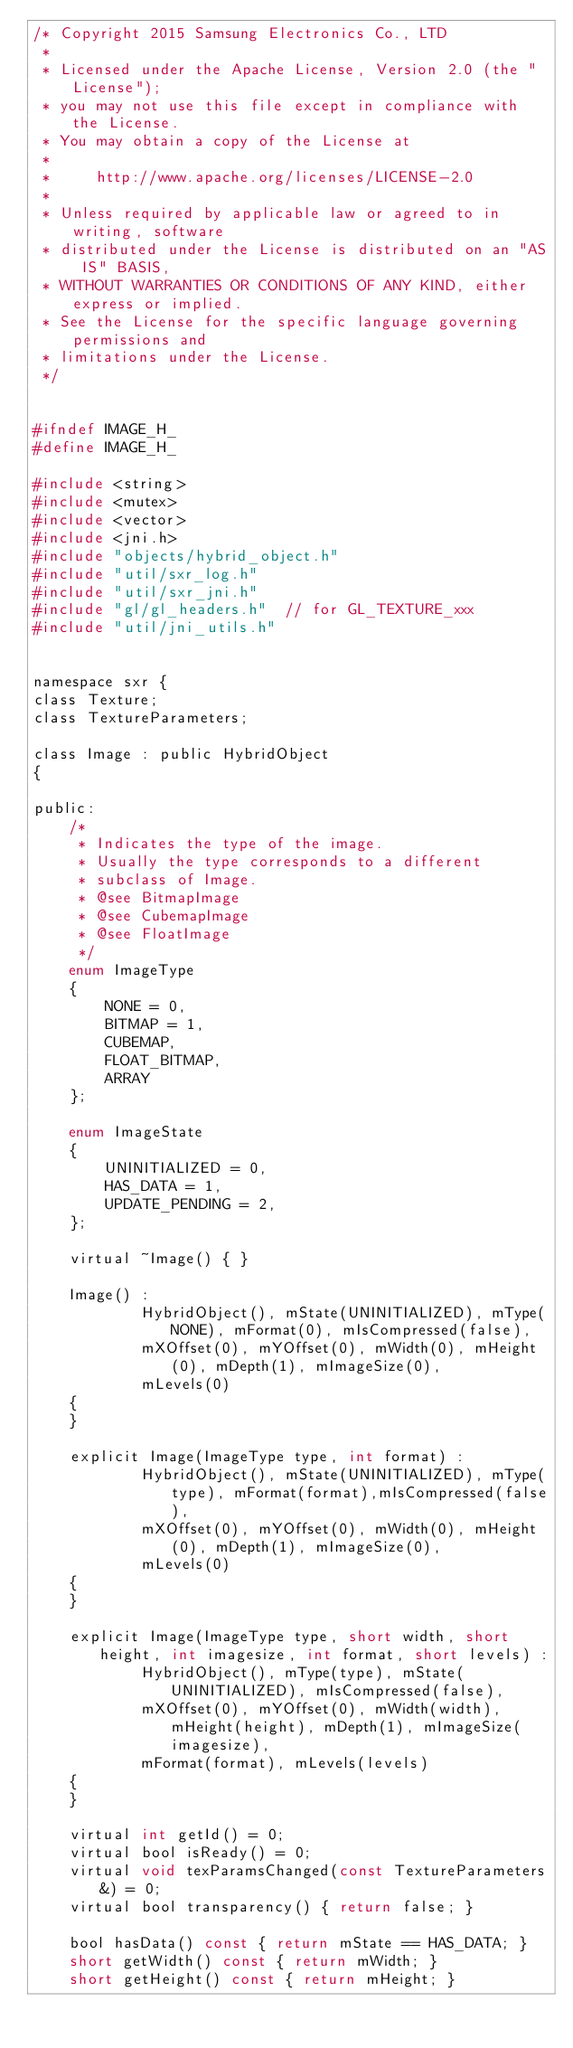Convert code to text. <code><loc_0><loc_0><loc_500><loc_500><_C_>/* Copyright 2015 Samsung Electronics Co., LTD
 *
 * Licensed under the Apache License, Version 2.0 (the "License");
 * you may not use this file except in compliance with the License.
 * You may obtain a copy of the License at
 *
 *     http://www.apache.org/licenses/LICENSE-2.0
 *
 * Unless required by applicable law or agreed to in writing, software
 * distributed under the License is distributed on an "AS IS" BASIS,
 * WITHOUT WARRANTIES OR CONDITIONS OF ANY KIND, either express or implied.
 * See the License for the specific language governing permissions and
 * limitations under the License.
 */


#ifndef IMAGE_H_
#define IMAGE_H_

#include <string>
#include <mutex>
#include <vector>
#include <jni.h>
#include "objects/hybrid_object.h"
#include "util/sxr_log.h"
#include "util/sxr_jni.h"
#include "gl/gl_headers.h"  // for GL_TEXTURE_xxx
#include "util/jni_utils.h"


namespace sxr {
class Texture;
class TextureParameters;

class Image : public HybridObject
{

public:
    /*
     * Indicates the type of the image.
     * Usually the type corresponds to a different
     * subclass of Image.
     * @see BitmapImage
     * @see CubemapImage
     * @see FloatImage
     */
    enum ImageType
    {
        NONE = 0,
        BITMAP = 1,
        CUBEMAP,
        FLOAT_BITMAP,
        ARRAY
    };

    enum ImageState
    {
        UNINITIALIZED = 0,
        HAS_DATA = 1,
        UPDATE_PENDING = 2,
    };

    virtual ~Image() { }

    Image() :
            HybridObject(), mState(UNINITIALIZED), mType(NONE), mFormat(0), mIsCompressed(false),
            mXOffset(0), mYOffset(0), mWidth(0), mHeight(0), mDepth(1), mImageSize(0),
            mLevels(0)
    {
    }

    explicit Image(ImageType type, int format) :
            HybridObject(), mState(UNINITIALIZED), mType(type), mFormat(format),mIsCompressed(false),
            mXOffset(0), mYOffset(0), mWidth(0), mHeight(0), mDepth(1), mImageSize(0),
            mLevels(0)
    {
    }

    explicit Image(ImageType type, short width, short height, int imagesize, int format, short levels) :
            HybridObject(), mType(type), mState(UNINITIALIZED), mIsCompressed(false),
            mXOffset(0), mYOffset(0), mWidth(width), mHeight(height), mDepth(1), mImageSize(imagesize),
            mFormat(format), mLevels(levels)
    {
    }

    virtual int getId() = 0;
    virtual bool isReady() = 0;
    virtual void texParamsChanged(const TextureParameters&) = 0;
    virtual bool transparency() { return false; }

    bool hasData() const { return mState == HAS_DATA; }
    short getWidth() const { return mWidth; }
    short getHeight() const { return mHeight; }</code> 